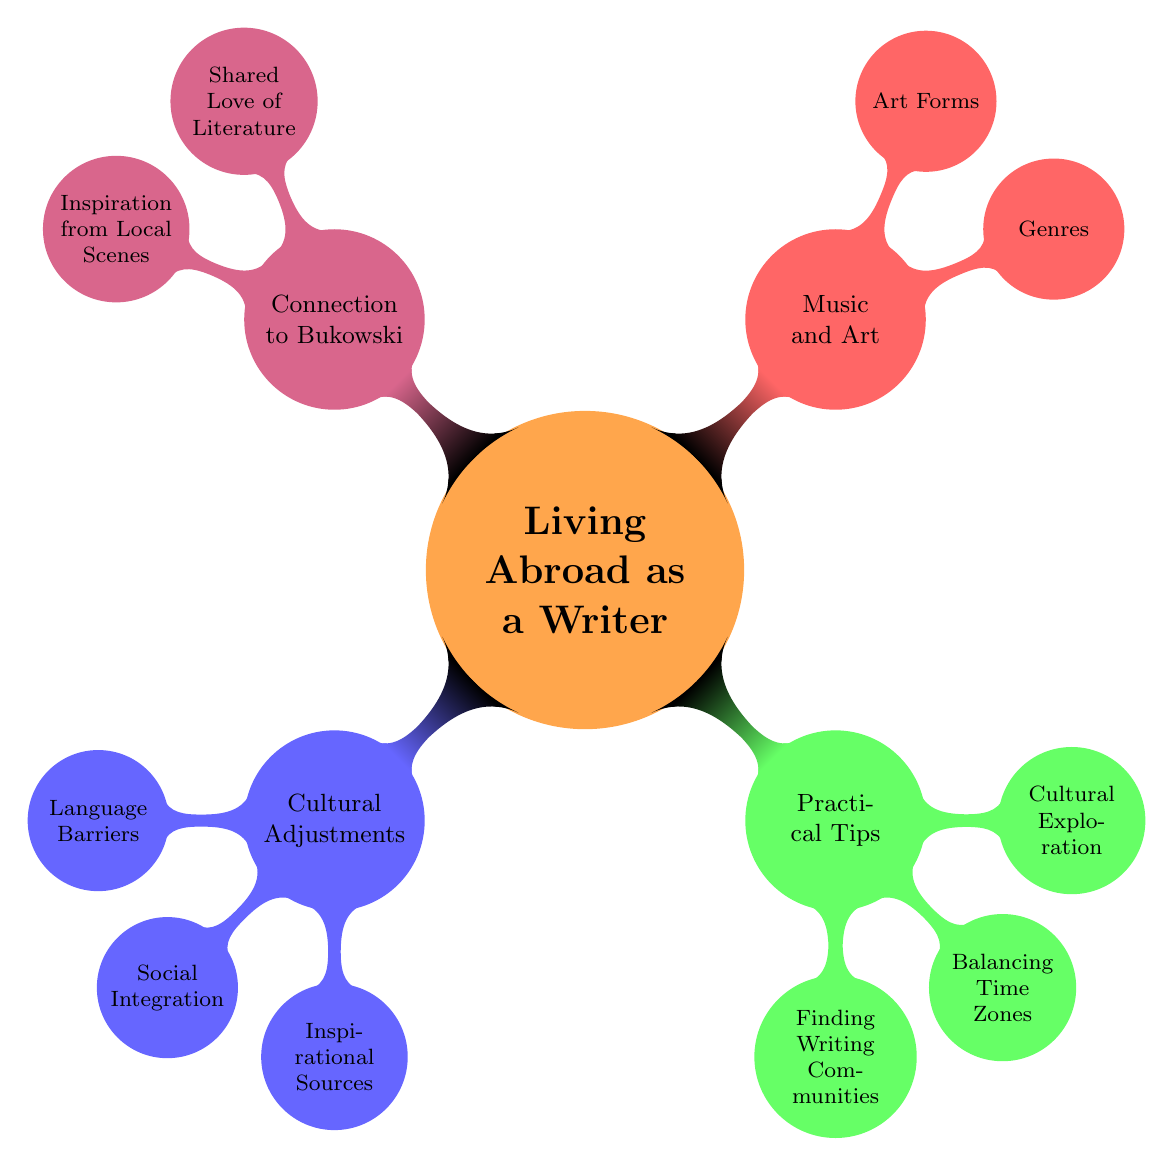What are the two main branches of the diagram? The diagram has two main branches: "Living Abroad as a Writer" and "Music and Art". "Living Abroad as a Writer" is the central theme, while "Music and Art" branches off as a related aspect.
Answer: Living Abroad as a Writer, Music and Art How many nodes are under "Cultural Adjustments"? "Cultural Adjustments" has three child nodes: "Language Barriers", "Social Integration", and "Inspirational Sources". Therefore, there are three nodes in total.
Answer: Three Which musical genre includes "Miles Davis"? "Miles Davis" is associated with the "Jazz" genre, as indicated in the "Genres" section of the diagram.
Answer: Jazz What is one practical tip listed in the diagram? One practical tip is "Finding Writing Communities", which is part of the "Practical Tips" section.
Answer: Finding Writing Communities Which two nodes are directly connected to "Living Abroad as a Writer"? The two nodes directly connected to "Living Abroad as a Writer" are "Cultural Adjustments" and "Practical Tips". These are the main categories representing adjustments and advice for writers living abroad.
Answer: Cultural Adjustments, Practical Tips What is the relationship between "Bukowski" and "Inspiration from Local Scenes"? "Bukowski" is linked to "Inspiration from Local Scenes" in the "Connection to Bukowski" section, suggesting that local art and experiences can inspire writers, connecting back to Bukowski's themes in literature.
Answer: Inspiration How many art forms are mentioned in the diagram? The diagram mentions three art forms: "Painting", "Literature", and "Cinema" under the "Art Forms" category. Hence, there are three art forms in total.
Answer: Three What section includes "Understanding Etiquette"? "Understanding Etiquette" is found under the "Social Integration" node within the "Cultural Adjustments" section, indicating the importance of social customs while living abroad.
Answer: Cultural Adjustments Which node connects to both "Local Art Scenes" and "New Daily Experiences"? "Inspirational Sources" connects to both "Local Art Scenes" and "New Daily Experiences", indicating sources of inspiration for writers living abroad.
Answer: Inspirational Sources 